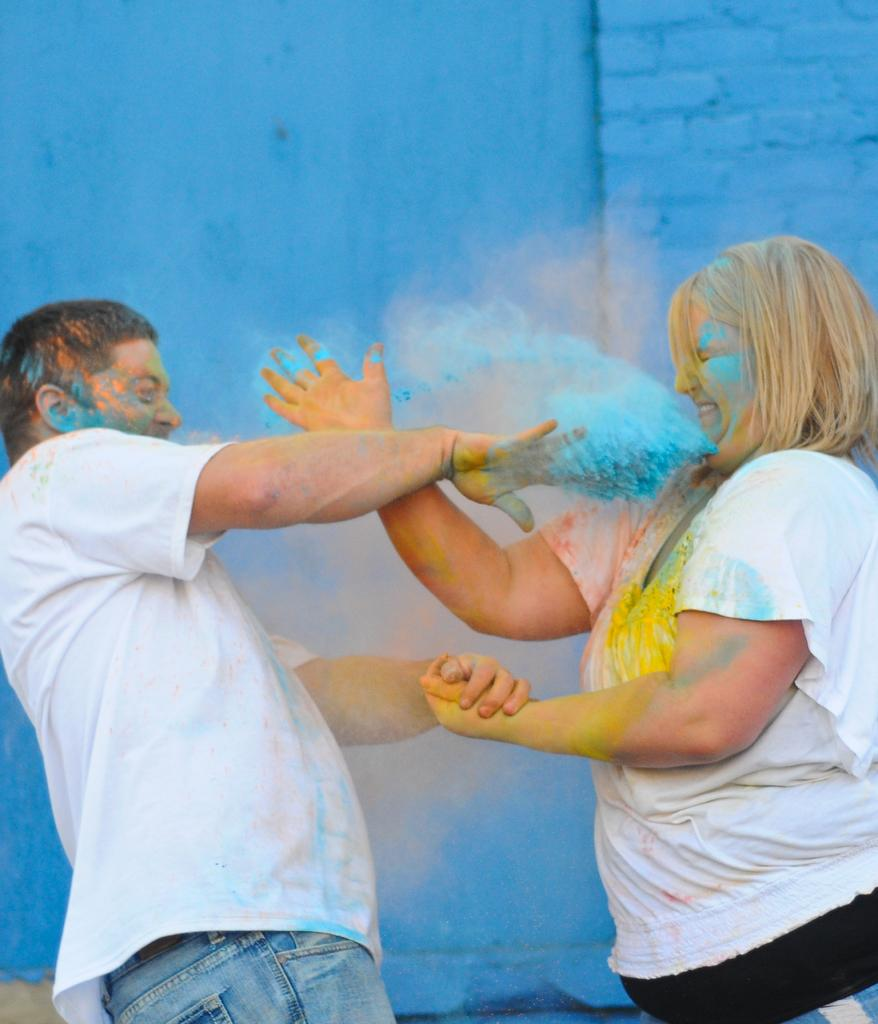How many people are in the image? There are two people in the image. What are the two people doing in the image? The two people are standing and playing holy. What can be seen in the background of the image? There is a wall in the background of the image. What color is the orange that the people are holding in the image? There is no orange present in the image; the two people are playing holy. How many cars can be seen in the image? There are no cars visible in the image. 